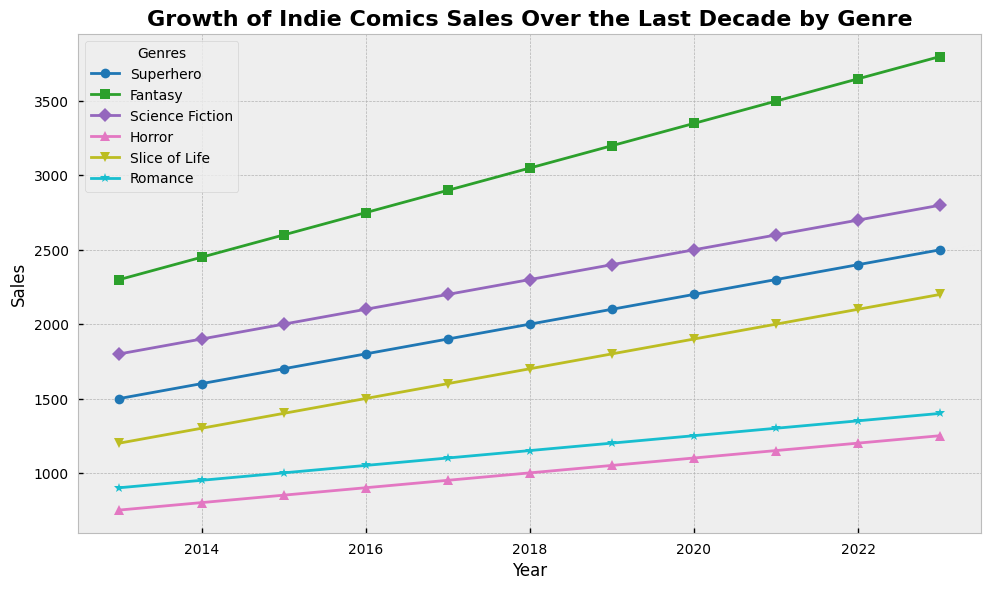What is the overall trend of Fantasy genre sales from 2013 to 2023? From 2013 to 2023, Fantasy genre sales show a steady increase every year. In 2013, the sales were 2300, and it reached 3800 in 2023. This indicates a positive upward trend over the decade.
Answer: Steady Increase Which genre shows the highest sales in 2023? By observing the lengths of the lines and their endpoints in 2023, Fantasy genre has the highest sales in 2023 with a sale number of 3800.
Answer: Fantasy What is the difference in sales between Science Fiction and Slice of Life genres in 2023? In 2023, Science Fiction sales are 2800, and Slice of Life sales are 2200. The difference is calculated as 2800 - 2200 = 600.
Answer: 600 Compare the rate of increase in sales between Superhero and Horror genres from 2013 to 2023. Which one increased more? Superhero sales increased from 1500 in 2013 to 2500 in 2023, a change of 1000. Horror sales increased from 750 in 2013 to 1250 in 2023, a change of 500. Thus, Superhero genre sales increased more.
Answer: Superhero What are the common visual markers used for each genre in the plot? The visual markers differentiate each genre: Superhero (circle), Fantasy (square), Science Fiction (diamond), Horror (triangle up), Slice of Life (triangle down), Romance (star).
Answer: Circle, Square, Diamond, Triangle Up, Triangle Down, Star What is the average sales number for the Romance genre over the decade? Summing up the sales numbers for Romance over the years (900 + 950 + 1000 + 1050 + 1100 + 1150 + 1200 + 1250 + 1300 + 1350 + 1400) gives 12650. There are 11 years, so the average is 12650 / 11 ≈ 1150.
Answer: 1150 In which year did Slice of Life genre first surpass 1500 in sales? Looking at the data points for the Slice of Life genre, the year it first surpasses 1500 is 2018, with sales of 1700.
Answer: 2018 How do the sales of Horror and Romance genres compare in 2020? In 2020, the sales for Horror are 1100, and for Romance, they are 1250. Romance has higher sales than Horror in that year.
Answer: Romance has higher sales Which genre had the smallest increase in sales from 2013 to 2023? Calculating the sales increase for each genre, the smallest increase is for Horror, which increased from 750 to 1250, a change of 500.
Answer: Horror What is the total combined sales of all genres in 2022? Summing the sales of all genres in 2022 (2400 + 3650 + 2700 + 1200 + 2100 + 1350) gives 13400 as the total combined sales for all genres.
Answer: 13400 